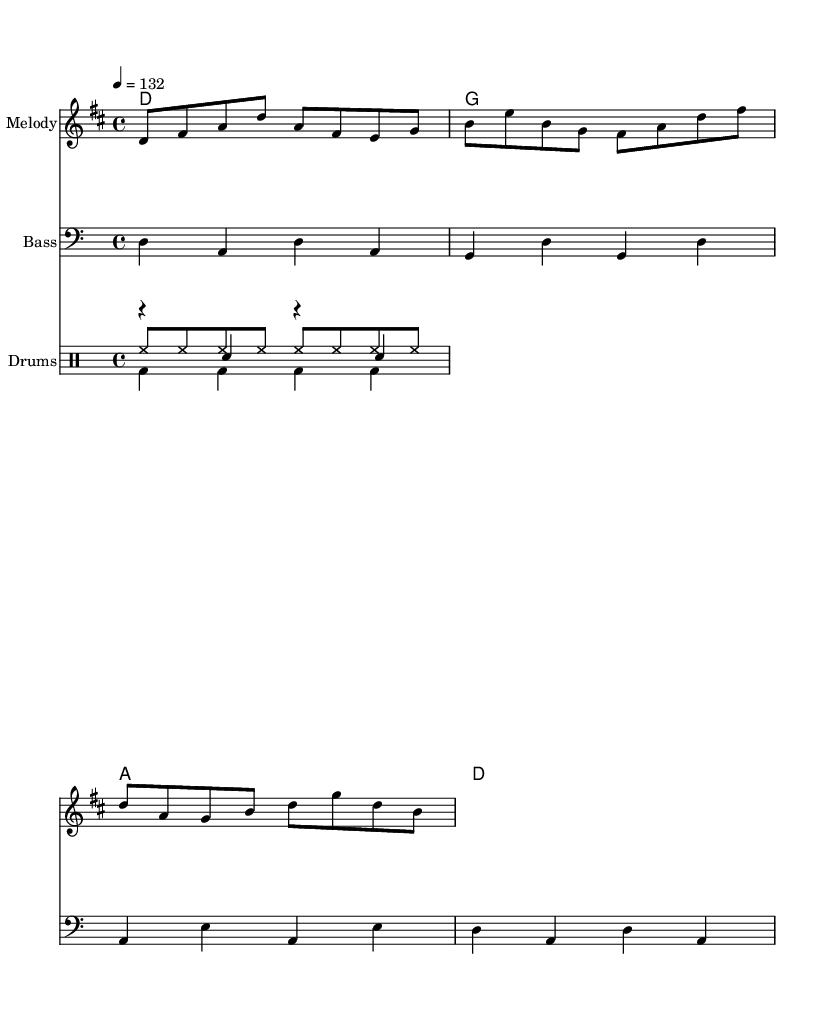What is the key signature of this music? The key signature is D major, which has two sharps (F# and C#).
Answer: D major What is the time signature of this piece? The time signature is 4/4, which means there are four beats in each measure, and the quarter note gets one beat.
Answer: 4/4 What is the tempo marking for this score? The tempo marking is 132 beats per minute, indicating the speed at which the piece should be played.
Answer: 132 How many measures are there in the melody? The melody consists of four measures, as counted by the grouping of notes separated by vertical lines.
Answer: 4 What is the main rhythmic pattern in the bassline? The main rhythmic pattern in the bassline primarily uses quarter notes, providing a steady underpinning to the melody and harmony.
Answer: Quarter notes What chords are used in this piece? The chords used in this piece are D, G, and A, which are all major chords and contribute to the upbeat nature of the anthem.
Answer: D, G, A What is the purpose of the drumming pattern in this composition? The drumming pattern, which includes a kick, snare, and hi-hat, establishes a driving rhythm appropriate for a corporate rock anthem, enhancing the overall energy of the piece.
Answer: Driving rhythm 